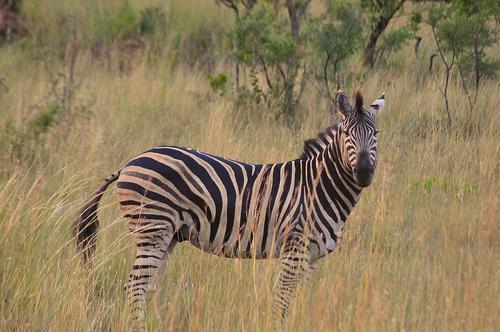How many zebras are in the photo?
Give a very brief answer. 1. 